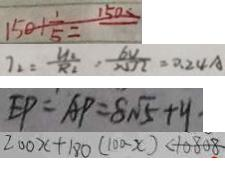<formula> <loc_0><loc_0><loc_500><loc_500>1 5 0 + \frac { 1 } { 5 } = 1 5 0 s 
 7 _ { 2 } = \frac { U _ { 2 } } { R _ { 2 } } , \frac { 6 v } { N \Omega } = 0 . 2 4 A 
 E P = A P = 8 \sqrt { 5 } + y . 
 2 0 0 x + 1 8 0 ( 1 0 0 - x ) < 1 0 8 0 8</formula> 